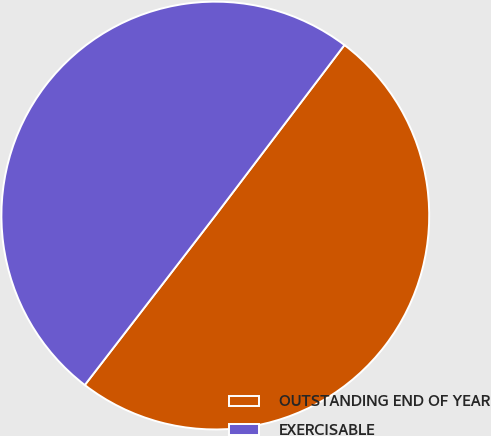Convert chart to OTSL. <chart><loc_0><loc_0><loc_500><loc_500><pie_chart><fcel>OUTSTANDING END OF YEAR<fcel>EXERCISABLE<nl><fcel>50.13%<fcel>49.87%<nl></chart> 